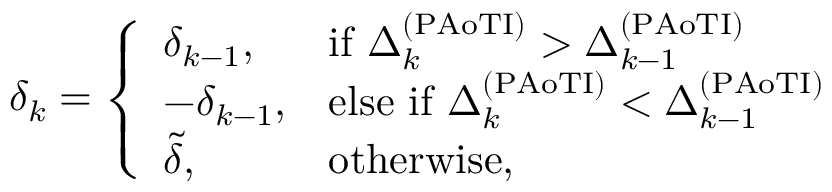Convert formula to latex. <formula><loc_0><loc_0><loc_500><loc_500>\begin{array} { r } { \delta _ { k } = \left \{ \begin{array} { l l } { \delta _ { k - 1 } , } & { i f \Delta _ { k } ^ { ( P A o T I ) } > \Delta _ { k - 1 } ^ { ( P A o T I ) } } \\ { - \delta _ { k - 1 } , } & { e l s e i f \Delta _ { k } ^ { ( P A o T I ) } < \Delta _ { k - 1 } ^ { ( P A o T I ) } } \\ { \tilde { \delta } , } & { o t h e r w i s e , } \end{array} } \end{array}</formula> 